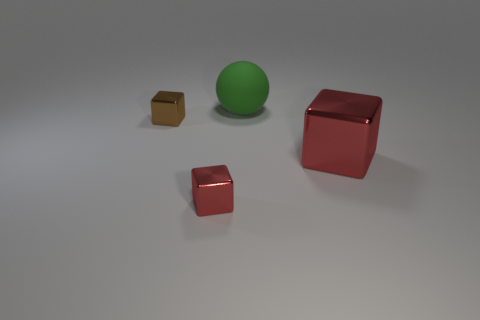Is there any other thing that is the same material as the large green sphere?
Offer a very short reply. No. How many large things have the same shape as the small brown thing?
Provide a succinct answer. 1. Does the red object right of the rubber object have the same material as the object that is behind the small brown object?
Provide a succinct answer. No. What is the size of the metallic block left of the small red thing that is left of the green sphere?
Offer a very short reply. Small. There is a brown metal object that is on the left side of the big green matte thing; does it have the same shape as the small metal object that is in front of the brown metallic block?
Provide a short and direct response. Yes. Are there more big objects than small blue metallic cubes?
Ensure brevity in your answer.  Yes. How big is the brown metal cube?
Keep it short and to the point. Small. What number of other things are there of the same color as the large rubber object?
Give a very brief answer. 0. Are the red cube right of the tiny red cube and the tiny brown cube made of the same material?
Make the answer very short. Yes. Are there fewer big matte spheres in front of the brown shiny block than small brown objects on the left side of the large rubber ball?
Give a very brief answer. Yes. 